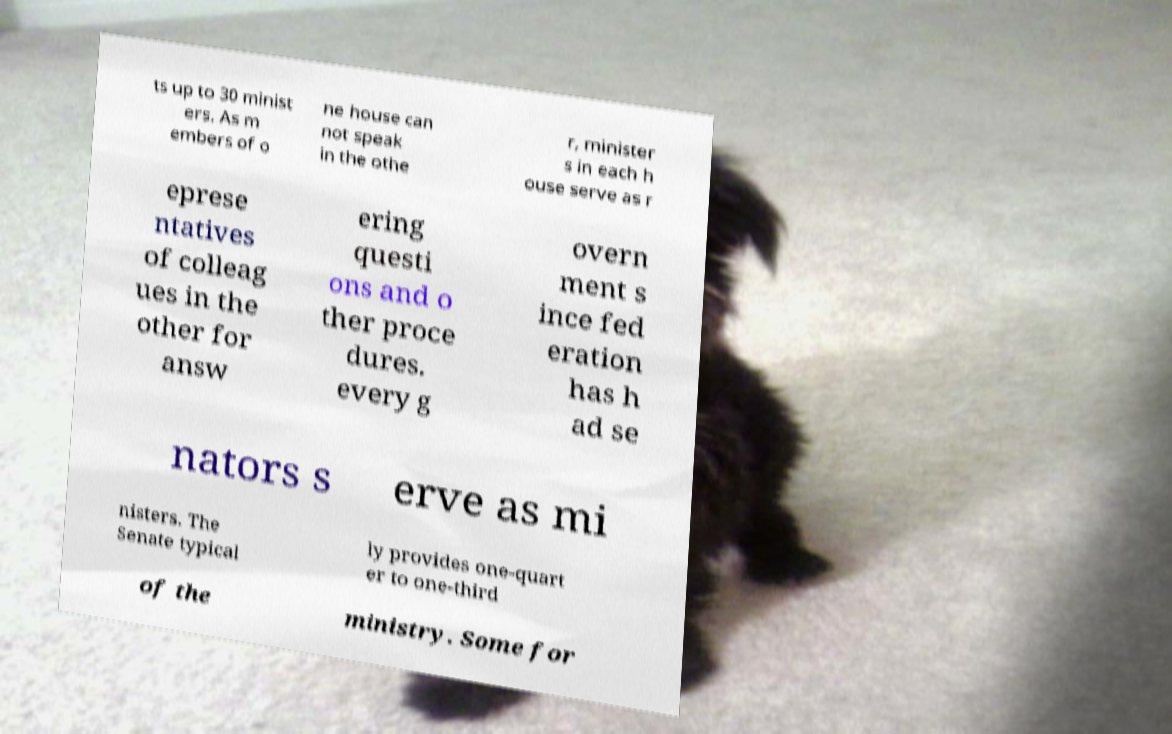Can you accurately transcribe the text from the provided image for me? ts up to 30 minist ers. As m embers of o ne house can not speak in the othe r, minister s in each h ouse serve as r eprese ntatives of colleag ues in the other for answ ering questi ons and o ther proce dures. every g overn ment s ince fed eration has h ad se nators s erve as mi nisters. The Senate typical ly provides one-quart er to one-third of the ministry. Some for 